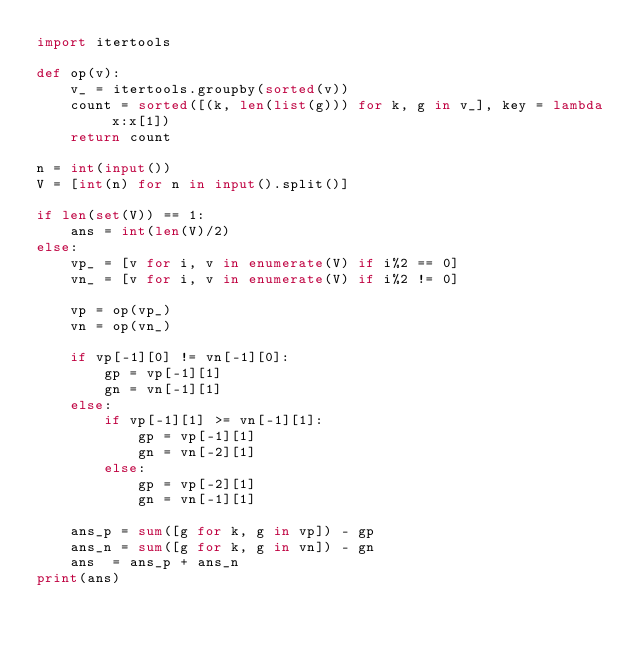<code> <loc_0><loc_0><loc_500><loc_500><_Python_>import itertools

def op(v):
    v_ = itertools.groupby(sorted(v))
    count = sorted([(k, len(list(g))) for k, g in v_], key = lambda x:x[1])
    return count

n = int(input())
V = [int(n) for n in input().split()]

if len(set(V)) == 1:
    ans = int(len(V)/2)
else:
    vp_ = [v for i, v in enumerate(V) if i%2 == 0] 
    vn_ = [v for i, v in enumerate(V) if i%2 != 0] 

    vp = op(vp_)
    vn = op(vn_)    

    if vp[-1][0] != vn[-1][0]:
        gp = vp[-1][1]
        gn = vn[-1][1]
    else:
        if vp[-1][1] >= vn[-1][1]:
            gp = vp[-1][1]
            gn = vn[-2][1]
        else:
            gp = vp[-2][1]
            gn = vn[-1][1]

    ans_p = sum([g for k, g in vp]) - gp
    ans_n = sum([g for k, g in vn]) - gn
    ans  = ans_p + ans_n
print(ans)</code> 